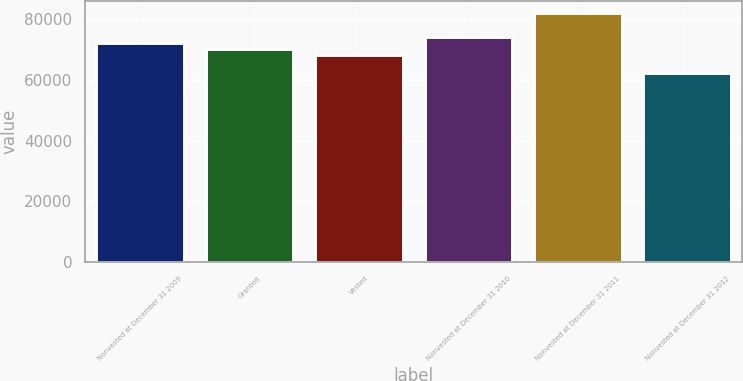<chart> <loc_0><loc_0><loc_500><loc_500><bar_chart><fcel>Nonvested at December 31 2009<fcel>Granted<fcel>Vested<fcel>Nonvested at December 31 2010<fcel>Nonvested at December 31 2011<fcel>Nonvested at December 31 2012<nl><fcel>72189.2<fcel>70227.6<fcel>68266<fcel>74150.8<fcel>81845<fcel>62229<nl></chart> 